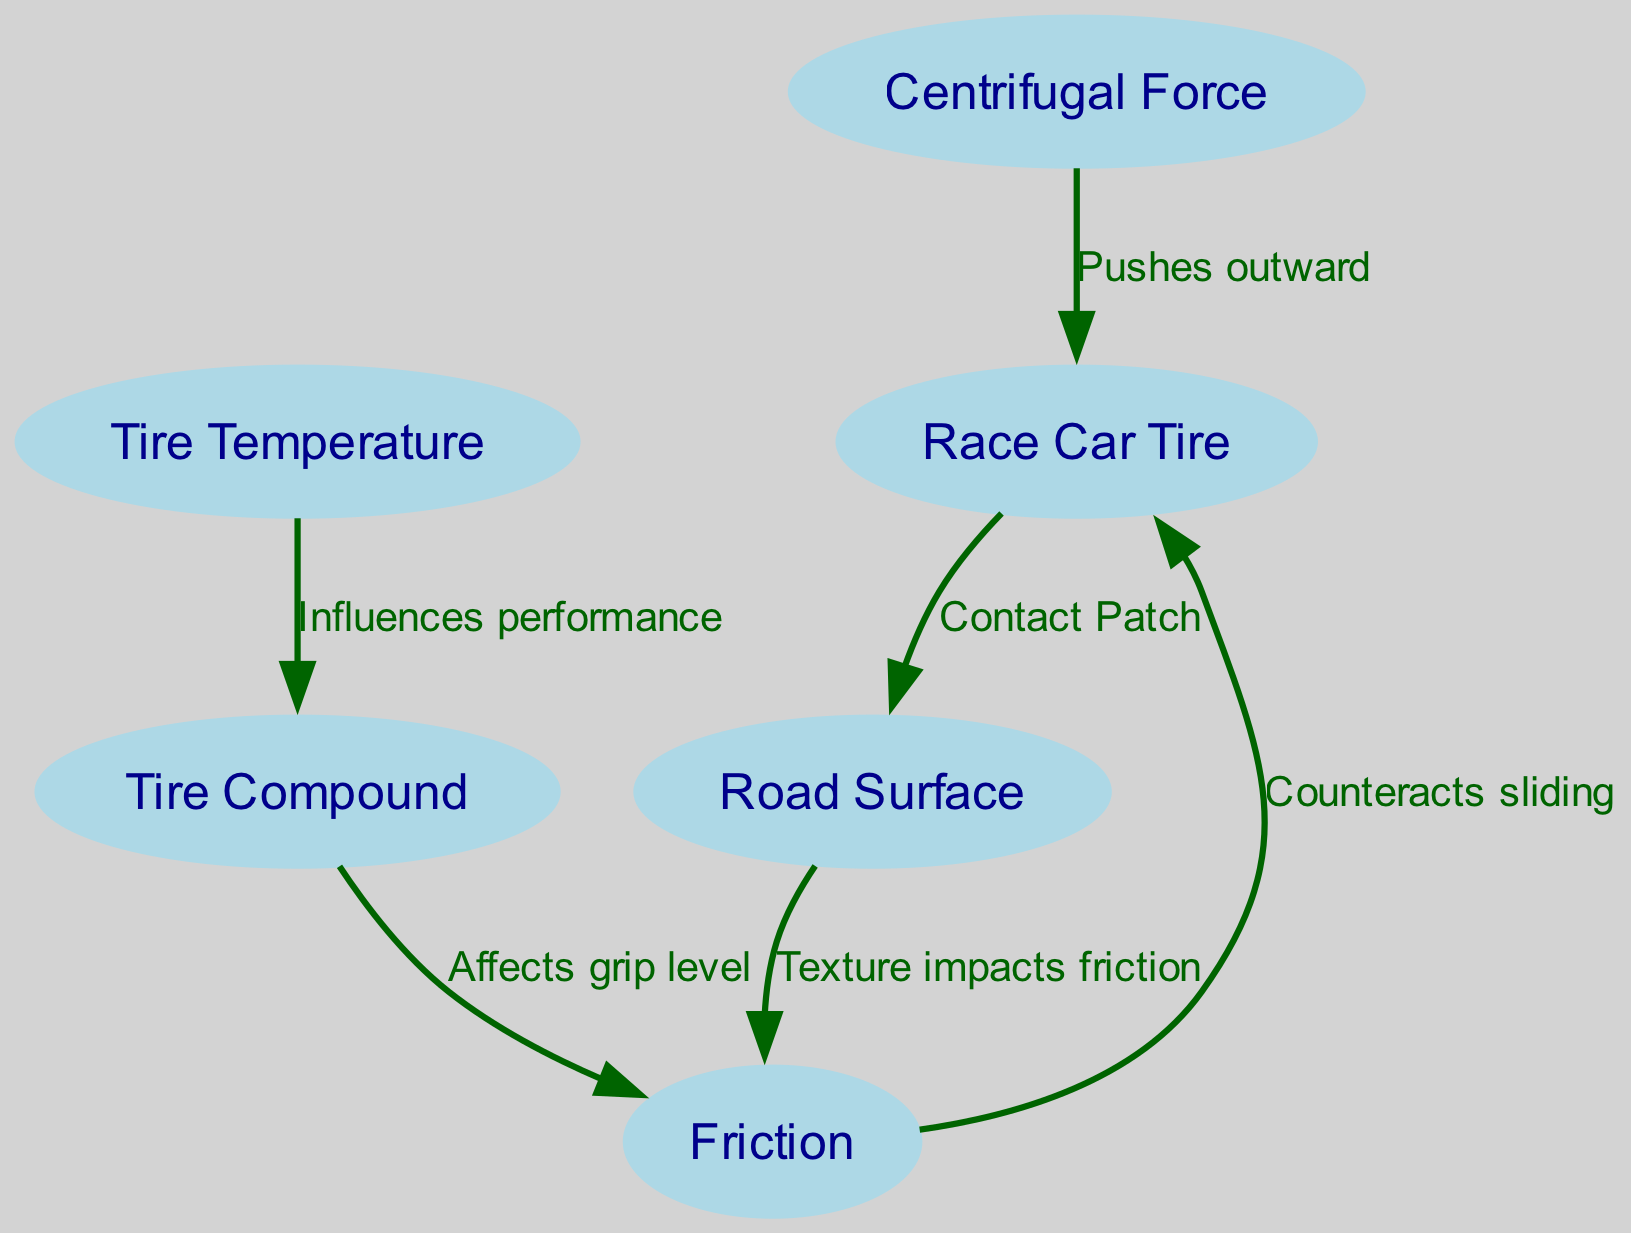What's the total number of nodes in the diagram? The diagram lists six distinct elements as nodes, which include the Race Car Tire, Road Surface, Centrifugal Force, Friction, Tire Compound, and Tire Temperature. Counting these gives a total of six nodes.
Answer: 6 What does the Friction node counteract? The diagram indicates that Friction counters sliding, as highlighted in the connection between the Friction node and the Race Car Tire node. This edge specifically notes that Friction serves to prevent the tire from losing grip and sliding out of control.
Answer: Sliding Which node influences Tire Compound? According to the edges in the diagram, the Tire Temperature node has a direct influence on the Tire Compound, as shown in the connection between the two nodes. This implies that changes in temperature affect the performance characteristics of the tire compound.
Answer: Tire Temperature What impact does Road Surface texture have? The diagram specifies that the Road Surface's texture impacts friction. This relationship indicates that different textures can alter the level of grip that a tire experiences when in contact with the road.
Answer: Friction How does Tire Compound affect grip level? The connection between the Tire Compound and Friction nodes reveals that Tire Compound directly affects the grip level of the tire. This means that variations in the material properties of the tire compound can influence how well the tire adheres to the road surface.
Answer: Grip level 